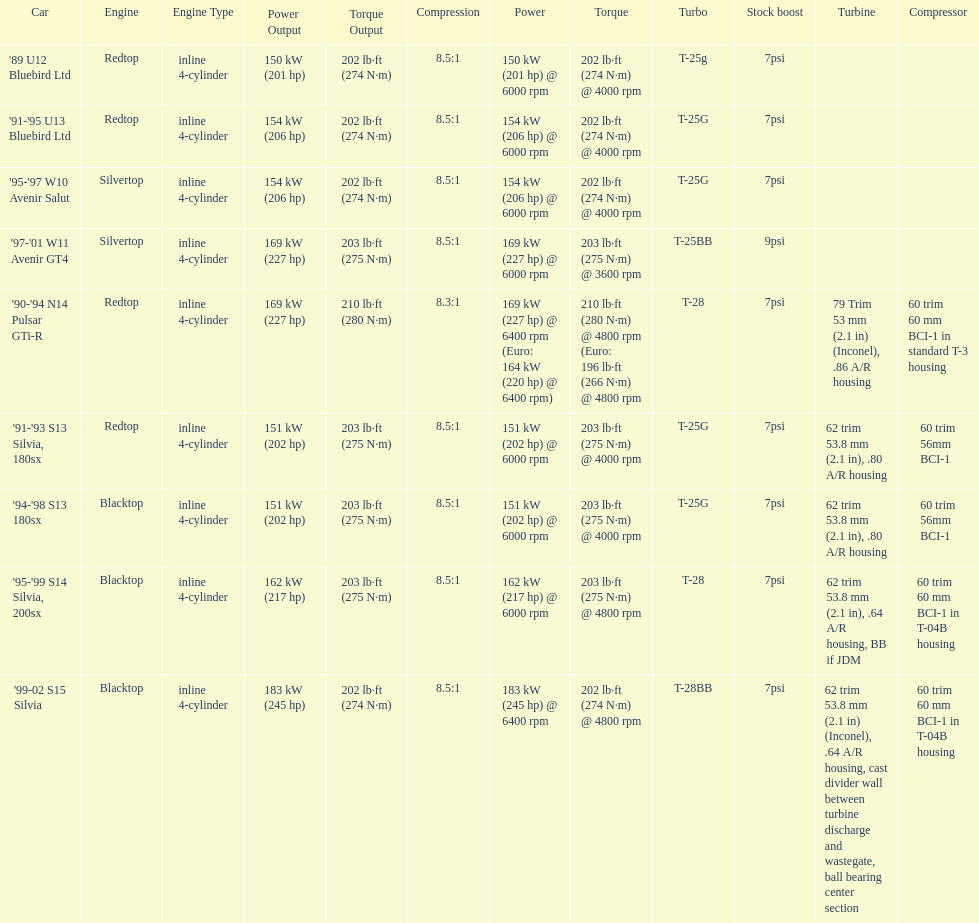Which car is the only one with more than 230 hp? '99-02 S15 Silvia. 